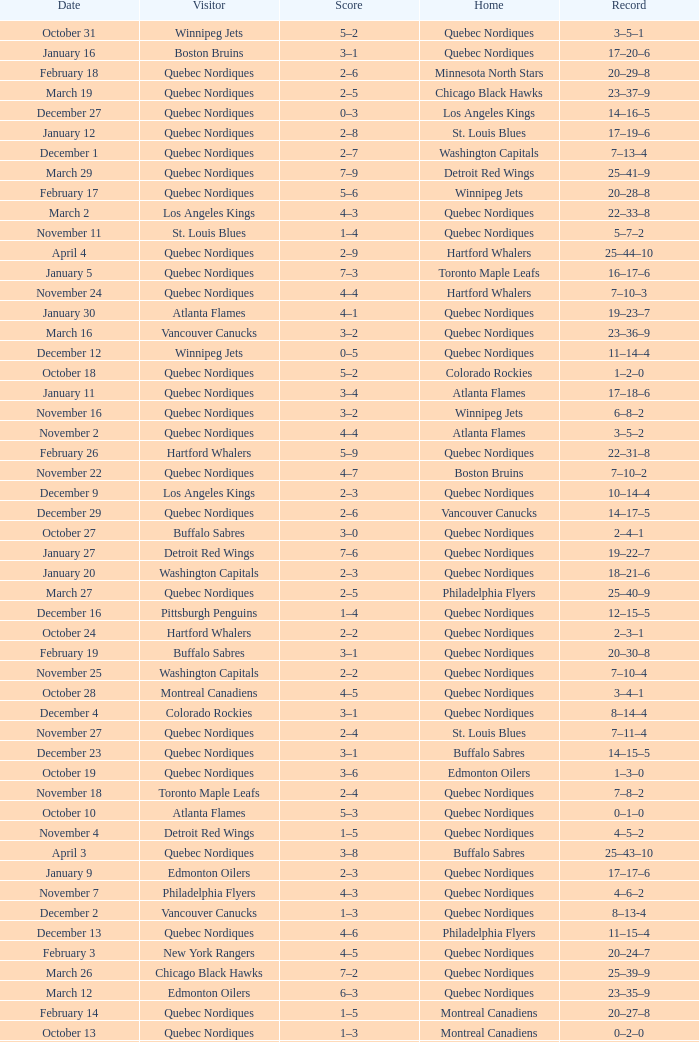Which Record has a Score of 2–4, and a Home of quebec nordiques? 7–8–2. 